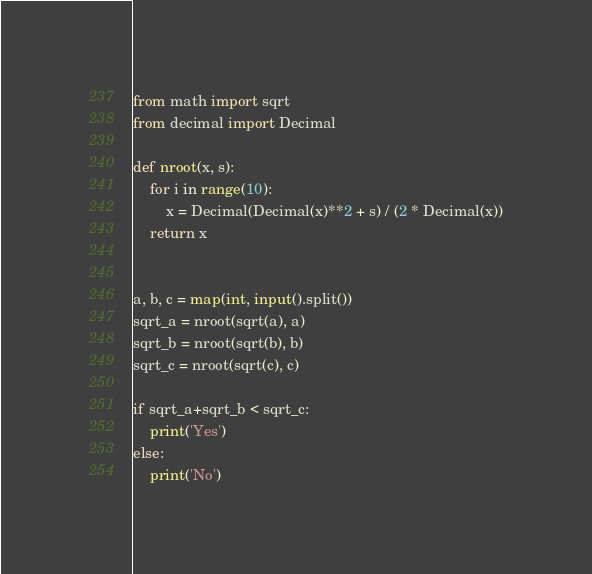Convert code to text. <code><loc_0><loc_0><loc_500><loc_500><_Python_>from math import sqrt
from decimal import Decimal

def nroot(x, s):
    for i in range(10):
        x = Decimal(Decimal(x)**2 + s) / (2 * Decimal(x))
    return x


a, b, c = map(int, input().split())
sqrt_a = nroot(sqrt(a), a)
sqrt_b = nroot(sqrt(b), b)
sqrt_c = nroot(sqrt(c), c)

if sqrt_a+sqrt_b < sqrt_c:
    print('Yes')
else:
    print('No')</code> 